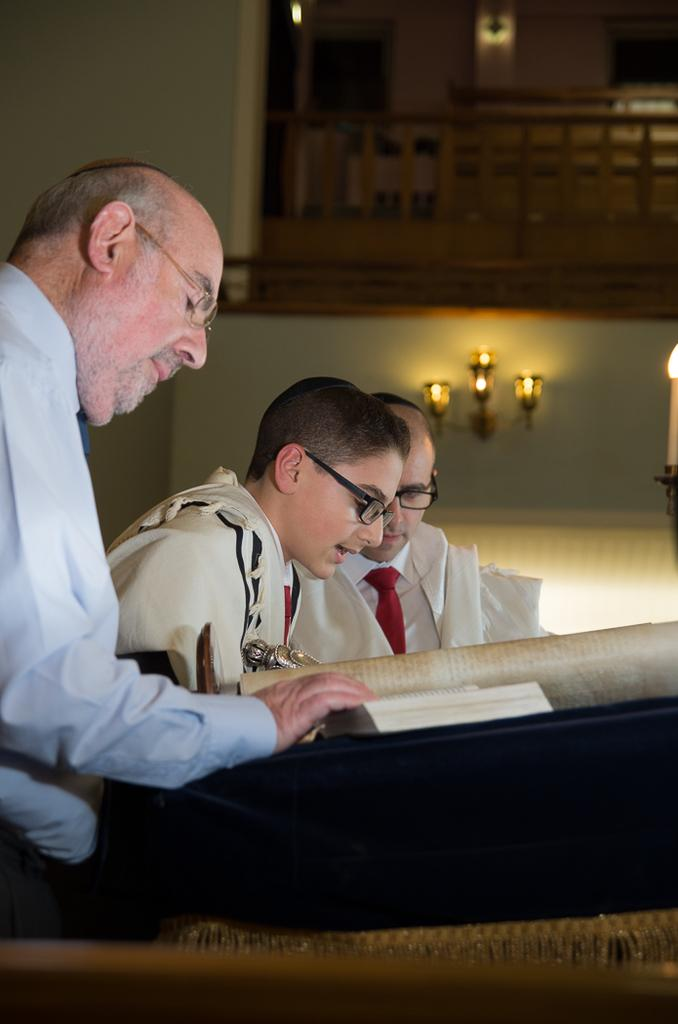What is the man on the left side of the image doing? The man is reading a book. What is the man wearing in the image? The man is wearing a shirt. What is the boy in the middle of the image doing? The boy is reading. What is the boy wearing in the image? The boy is wearing a dress and spectacles. What can be seen on the wall in the image? There are lights on the wall in the image. What type of gun is the man holding in the image? There is no gun present in the image; the man is reading a book. What color is the silver sock on the boy's foot in the image? There is no mention of a sock, silver or otherwise, in the image. The boy is wearing a dress and spectacles. 